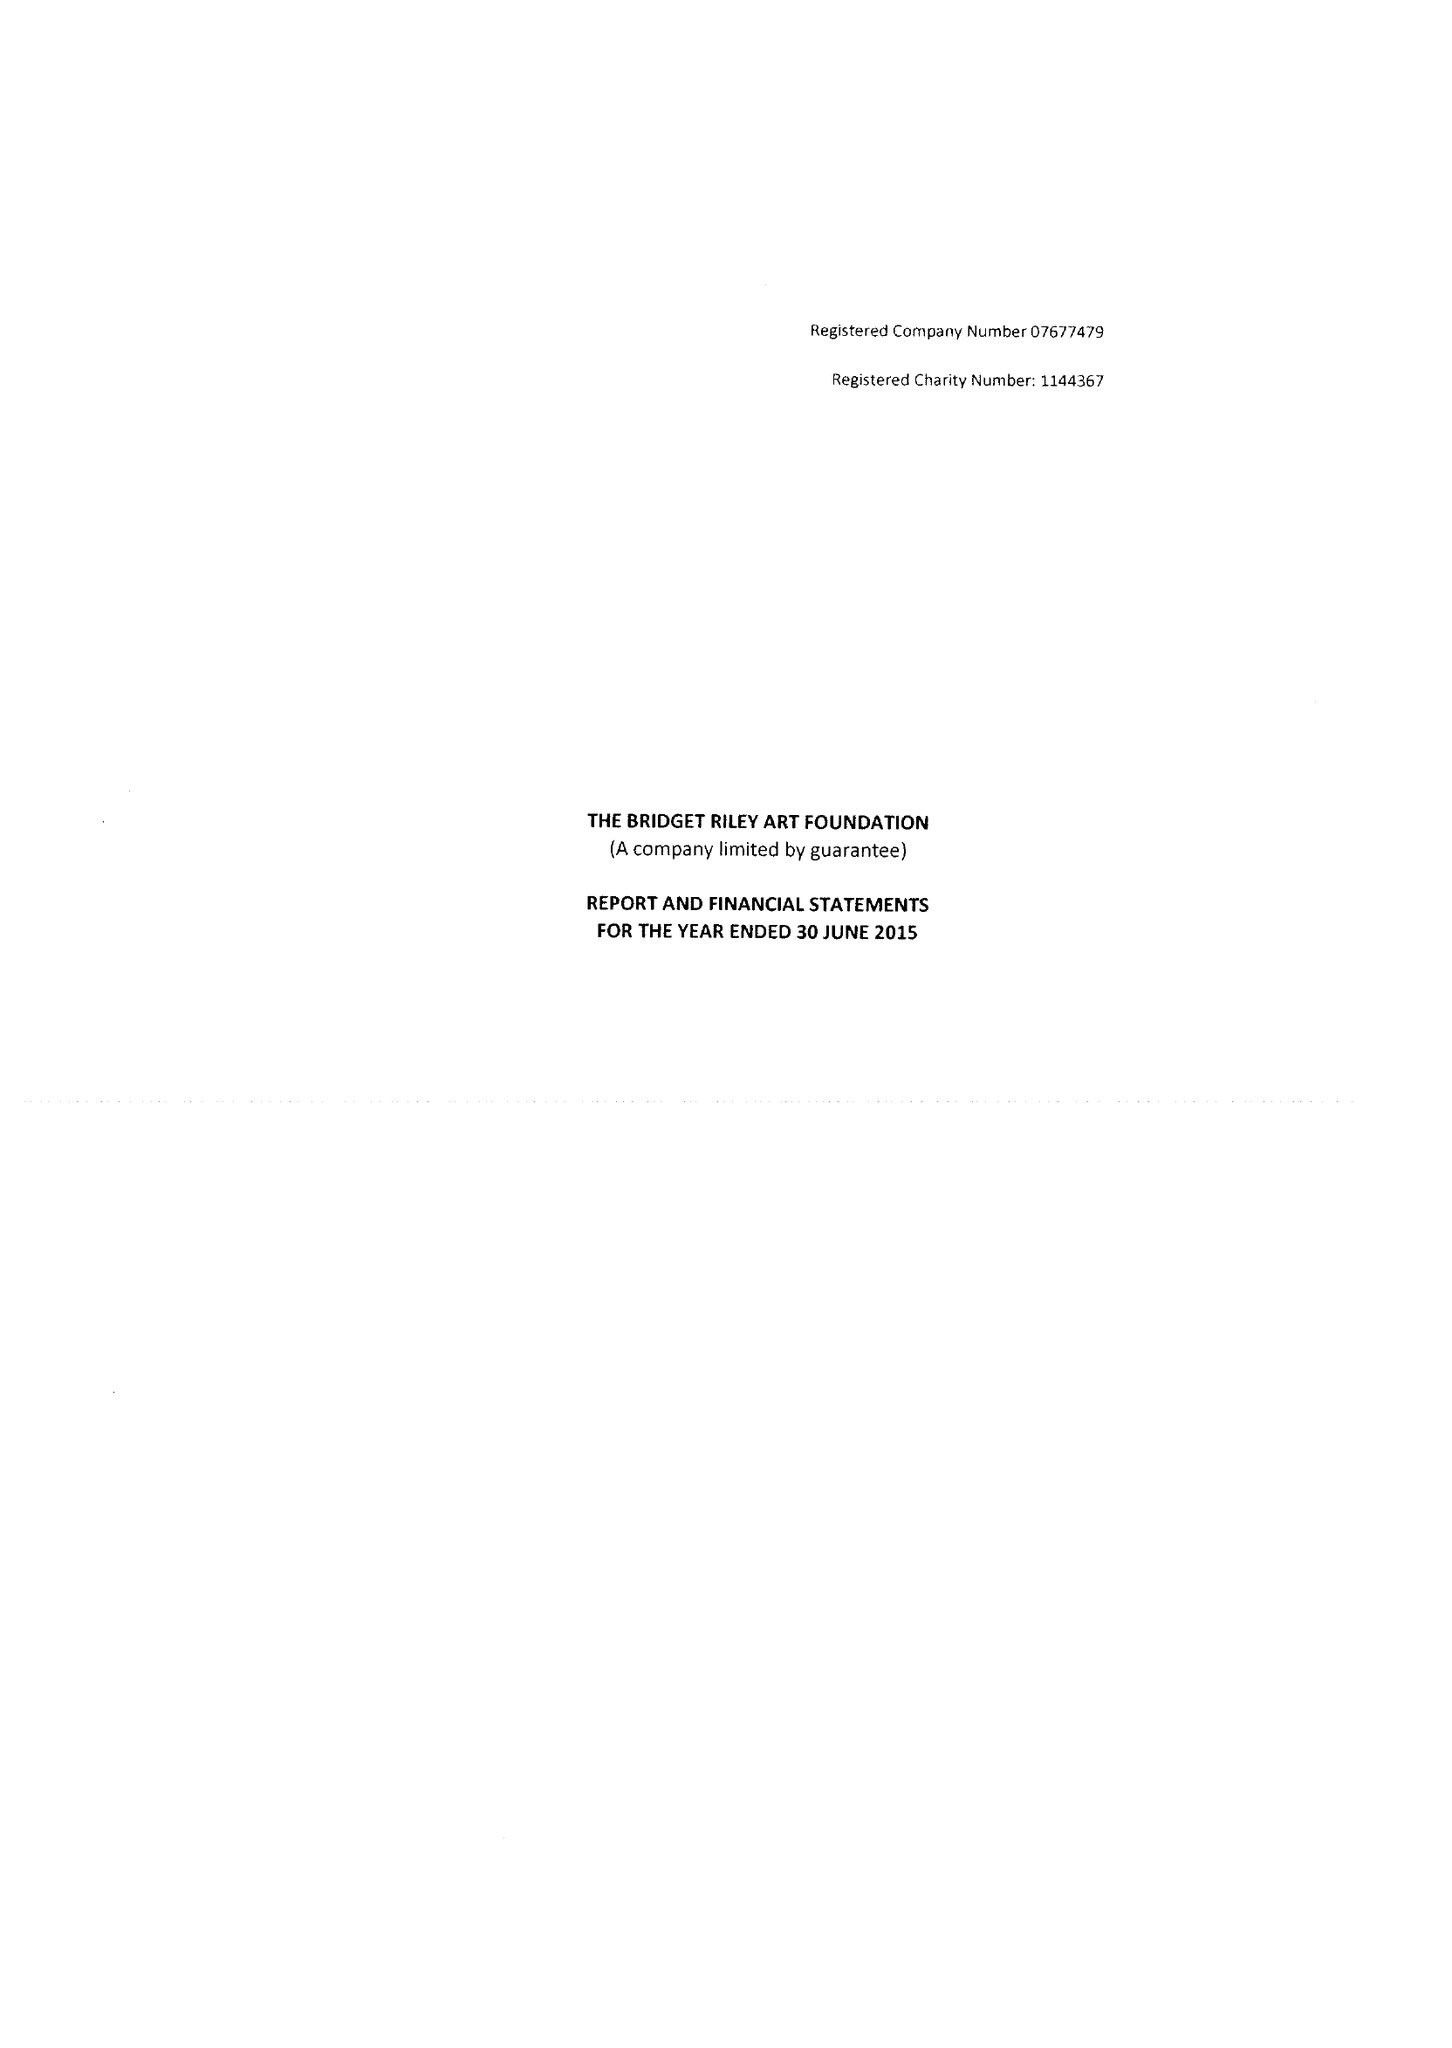What is the value for the address__street_line?
Answer the question using a single word or phrase. 7 ROYAL CRESCENT 